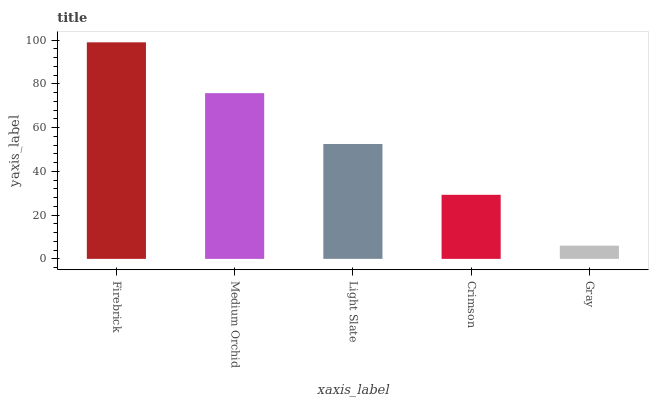Is Medium Orchid the minimum?
Answer yes or no. No. Is Medium Orchid the maximum?
Answer yes or no. No. Is Firebrick greater than Medium Orchid?
Answer yes or no. Yes. Is Medium Orchid less than Firebrick?
Answer yes or no. Yes. Is Medium Orchid greater than Firebrick?
Answer yes or no. No. Is Firebrick less than Medium Orchid?
Answer yes or no. No. Is Light Slate the high median?
Answer yes or no. Yes. Is Light Slate the low median?
Answer yes or no. Yes. Is Crimson the high median?
Answer yes or no. No. Is Firebrick the low median?
Answer yes or no. No. 